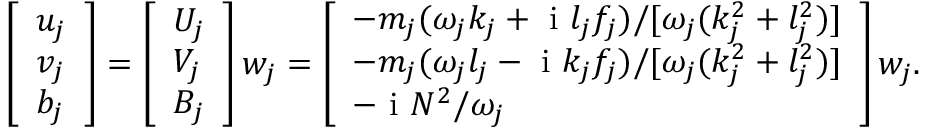<formula> <loc_0><loc_0><loc_500><loc_500>\begin{array} { r } { \left [ \begin{array} { l } { u _ { j } } \\ { v _ { j } } \\ { b _ { j } } \end{array} \right ] = \left [ \begin{array} { l } { U _ { j } } \\ { V _ { j } } \\ { B _ { j } } \end{array} \right ] w _ { j } = \left [ \begin{array} { l } { - { m _ { j } ( \omega _ { j } k _ { j } + i l _ { j } f _ { j } ) } { / [ \omega _ { j } ( k _ { j } ^ { 2 } + l _ { j } ^ { 2 } ) ] } } \\ { - { m _ { j } ( \omega _ { j } l _ { j } - i k _ { j } f _ { j } ) } { / [ \omega _ { j } ( k _ { j } ^ { 2 } + l _ { j } ^ { 2 } ) ] } } \\ { - i { N ^ { 2 } } { / \omega _ { j } } } \end{array} \right ] w _ { j } . } \end{array}</formula> 